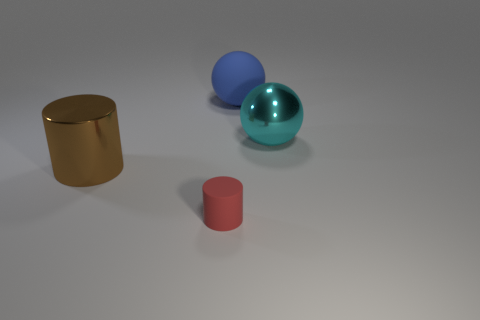Describe a possible educational use for these items in the image. These items could be used in an educational context to teach various concepts. For instance, they could be props for a lesson on geometry, discussing the properties of cylinders and spheres, such as volume and surface area. Additionally, they could serve as tools in a physics class to demonstrate the principles of light and reflection, considering their various textures and finishes which reflect light differently. Another use might be in a color theory lesson, where students discuss primary colors, shades, and how different lighting affects the perception of color on various materials. 